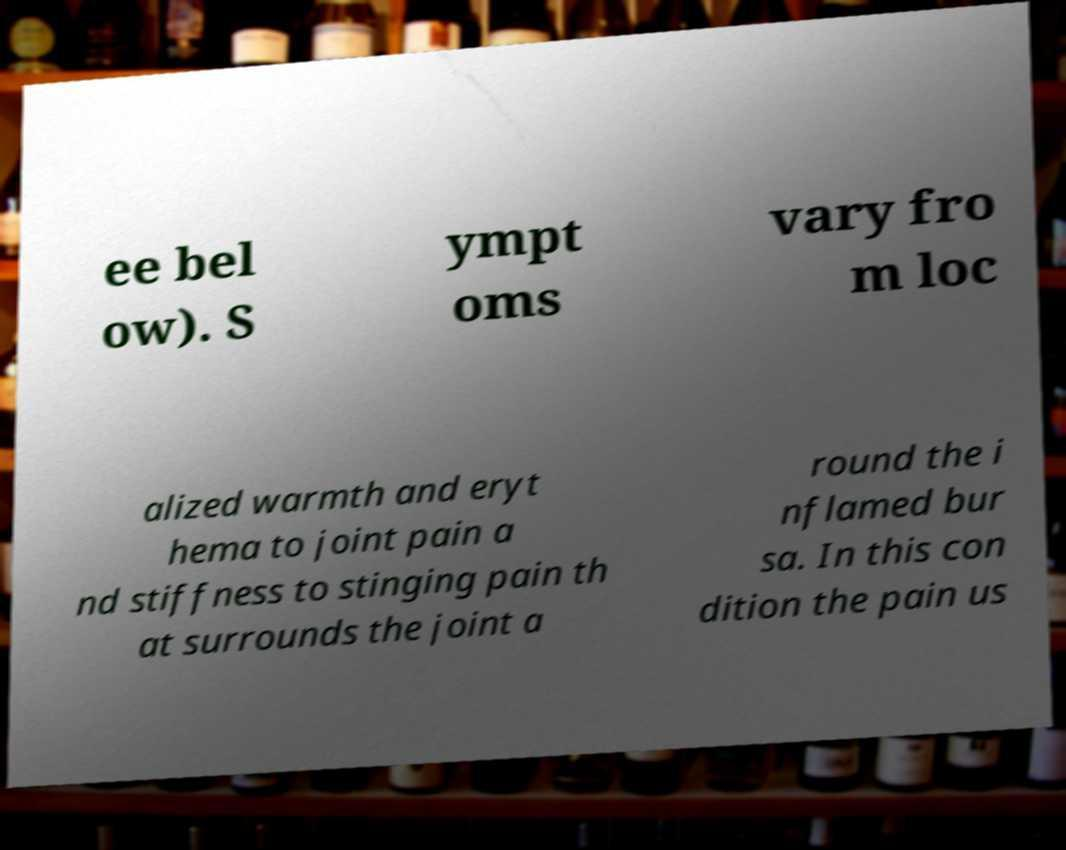Could you assist in decoding the text presented in this image and type it out clearly? ee bel ow). S ympt oms vary fro m loc alized warmth and eryt hema to joint pain a nd stiffness to stinging pain th at surrounds the joint a round the i nflamed bur sa. In this con dition the pain us 